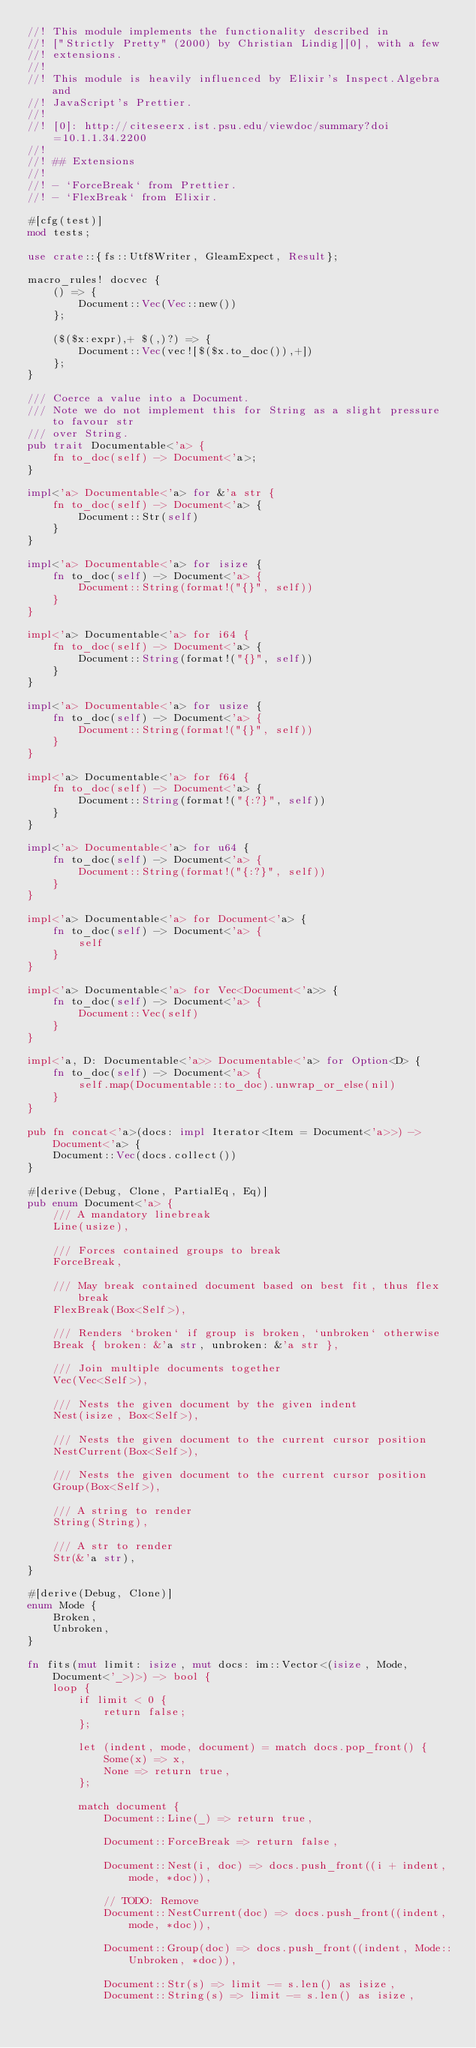<code> <loc_0><loc_0><loc_500><loc_500><_Rust_>//! This module implements the functionality described in
//! ["Strictly Pretty" (2000) by Christian Lindig][0], with a few
//! extensions.
//!
//! This module is heavily influenced by Elixir's Inspect.Algebra and
//! JavaScript's Prettier.
//!
//! [0]: http://citeseerx.ist.psu.edu/viewdoc/summary?doi=10.1.1.34.2200
//!
//! ## Extensions
//!
//! - `ForceBreak` from Prettier.
//! - `FlexBreak` from Elixir.

#[cfg(test)]
mod tests;

use crate::{fs::Utf8Writer, GleamExpect, Result};

macro_rules! docvec {
    () => {
        Document::Vec(Vec::new())
    };

    ($($x:expr),+ $(,)?) => {
        Document::Vec(vec![$($x.to_doc()),+])
    };
}

/// Coerce a value into a Document.
/// Note we do not implement this for String as a slight pressure to favour str
/// over String.
pub trait Documentable<'a> {
    fn to_doc(self) -> Document<'a>;
}

impl<'a> Documentable<'a> for &'a str {
    fn to_doc(self) -> Document<'a> {
        Document::Str(self)
    }
}

impl<'a> Documentable<'a> for isize {
    fn to_doc(self) -> Document<'a> {
        Document::String(format!("{}", self))
    }
}

impl<'a> Documentable<'a> for i64 {
    fn to_doc(self) -> Document<'a> {
        Document::String(format!("{}", self))
    }
}

impl<'a> Documentable<'a> for usize {
    fn to_doc(self) -> Document<'a> {
        Document::String(format!("{}", self))
    }
}

impl<'a> Documentable<'a> for f64 {
    fn to_doc(self) -> Document<'a> {
        Document::String(format!("{:?}", self))
    }
}

impl<'a> Documentable<'a> for u64 {
    fn to_doc(self) -> Document<'a> {
        Document::String(format!("{:?}", self))
    }
}

impl<'a> Documentable<'a> for Document<'a> {
    fn to_doc(self) -> Document<'a> {
        self
    }
}

impl<'a> Documentable<'a> for Vec<Document<'a>> {
    fn to_doc(self) -> Document<'a> {
        Document::Vec(self)
    }
}

impl<'a, D: Documentable<'a>> Documentable<'a> for Option<D> {
    fn to_doc(self) -> Document<'a> {
        self.map(Documentable::to_doc).unwrap_or_else(nil)
    }
}

pub fn concat<'a>(docs: impl Iterator<Item = Document<'a>>) -> Document<'a> {
    Document::Vec(docs.collect())
}

#[derive(Debug, Clone, PartialEq, Eq)]
pub enum Document<'a> {
    /// A mandatory linebreak
    Line(usize),

    /// Forces contained groups to break
    ForceBreak,

    /// May break contained document based on best fit, thus flex break
    FlexBreak(Box<Self>),

    /// Renders `broken` if group is broken, `unbroken` otherwise
    Break { broken: &'a str, unbroken: &'a str },

    /// Join multiple documents together
    Vec(Vec<Self>),

    /// Nests the given document by the given indent
    Nest(isize, Box<Self>),

    /// Nests the given document to the current cursor position
    NestCurrent(Box<Self>),

    /// Nests the given document to the current cursor position
    Group(Box<Self>),

    /// A string to render
    String(String),

    /// A str to render
    Str(&'a str),
}

#[derive(Debug, Clone)]
enum Mode {
    Broken,
    Unbroken,
}

fn fits(mut limit: isize, mut docs: im::Vector<(isize, Mode, Document<'_>)>) -> bool {
    loop {
        if limit < 0 {
            return false;
        };

        let (indent, mode, document) = match docs.pop_front() {
            Some(x) => x,
            None => return true,
        };

        match document {
            Document::Line(_) => return true,

            Document::ForceBreak => return false,

            Document::Nest(i, doc) => docs.push_front((i + indent, mode, *doc)),

            // TODO: Remove
            Document::NestCurrent(doc) => docs.push_front((indent, mode, *doc)),

            Document::Group(doc) => docs.push_front((indent, Mode::Unbroken, *doc)),

            Document::Str(s) => limit -= s.len() as isize,
            Document::String(s) => limit -= s.len() as isize,
</code> 